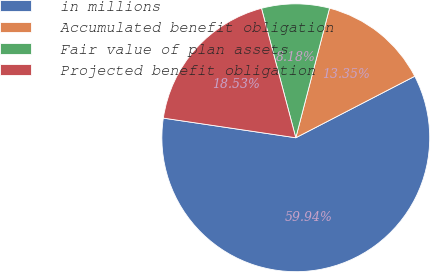<chart> <loc_0><loc_0><loc_500><loc_500><pie_chart><fcel>in millions<fcel>Accumulated benefit obligation<fcel>Fair value of plan assets<fcel>Projected benefit obligation<nl><fcel>59.94%<fcel>13.35%<fcel>8.18%<fcel>18.53%<nl></chart> 